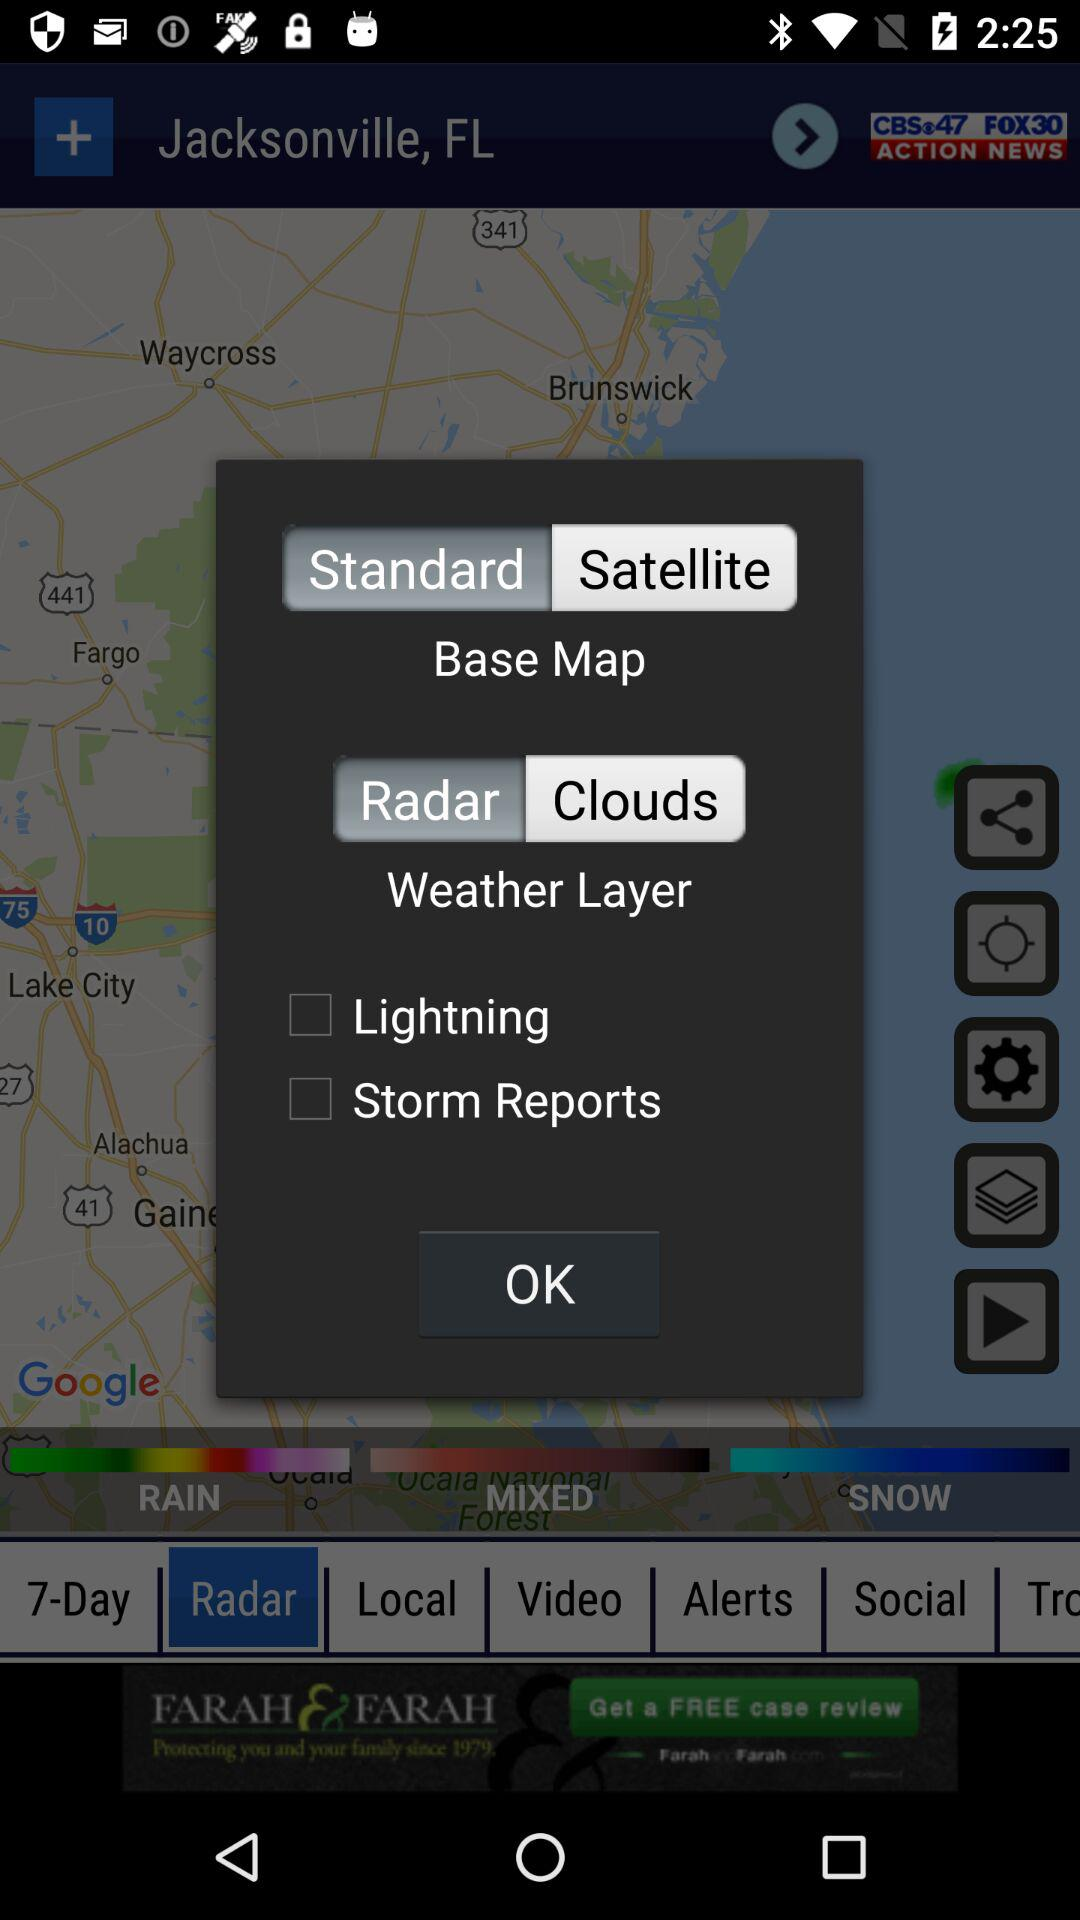What type of base map is selected? The selected type of base map is "Standard". 